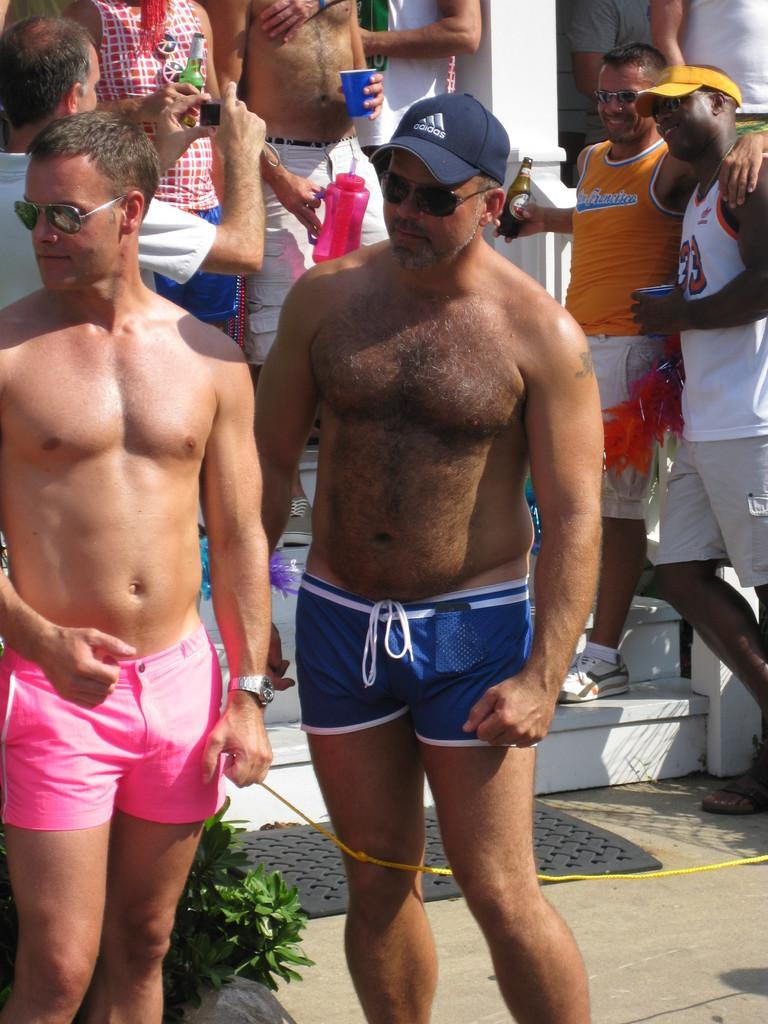How many people are in the image? There are people in the image, but the exact number is not specified in the facts. What are the people holding in the image? The people are holding bottles and cups in the image. What architectural feature can be seen in the image? There are steps in the image. What is located in front of the steps? There is a plant and a mat in front of the steps in the image. What other object can be seen in the image? There is a rope in the image. What is the value of the number written on the paste in the image? There is no paste or number present in the image. 